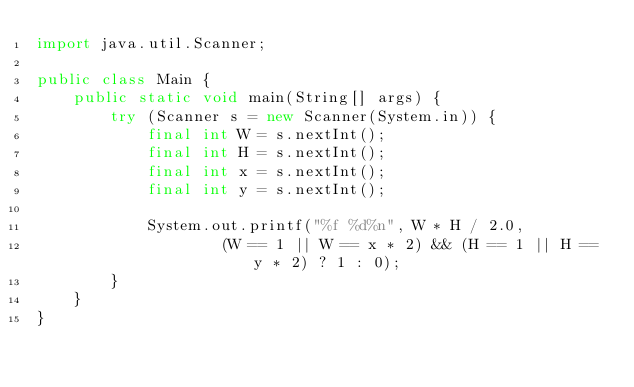Convert code to text. <code><loc_0><loc_0><loc_500><loc_500><_Java_>import java.util.Scanner;

public class Main {
	public static void main(String[] args) {
		try (Scanner s = new Scanner(System.in)) {
			final int W = s.nextInt();
			final int H = s.nextInt();
			final int x = s.nextInt();
			final int y = s.nextInt();

			System.out.printf("%f %d%n", W * H / 2.0,
					(W == 1 || W == x * 2) && (H == 1 || H == y * 2) ? 1 : 0);
		}
	}
}
</code> 